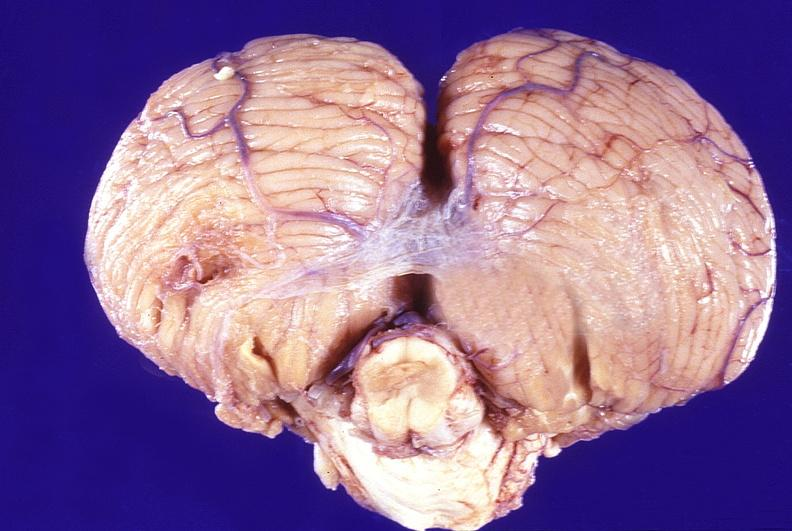what does this image show?
Answer the question using a single word or phrase. Normal brain 